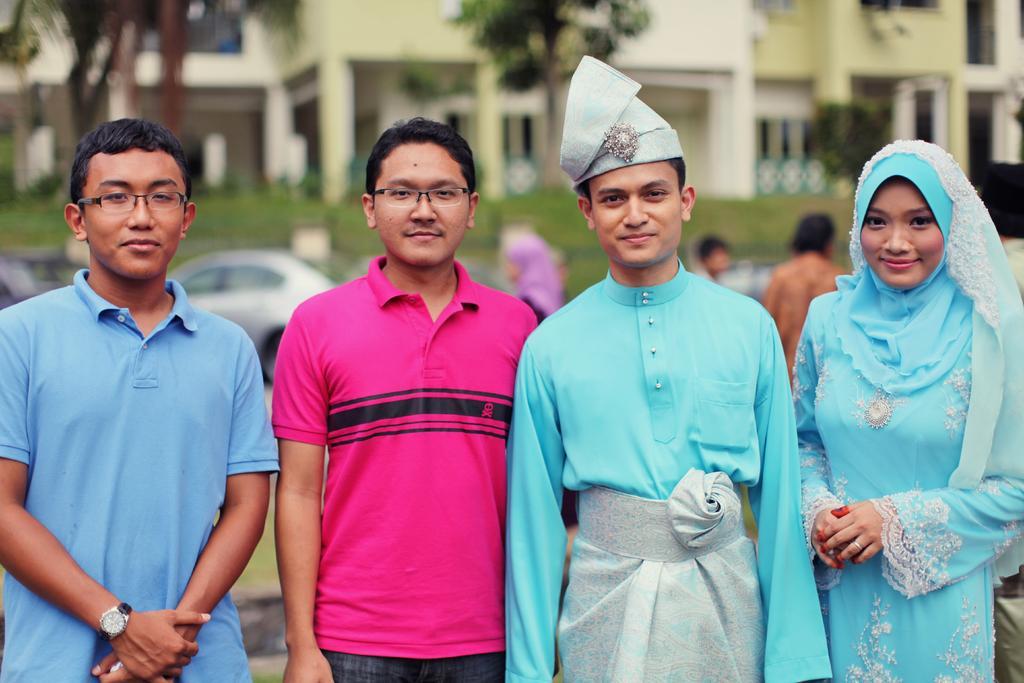In one or two sentences, can you explain what this image depicts? In this image I can see few people are standing. I can see two of them are wearing specs and I can also see smile on few faces. In the background I can see few buildings, trees, few vehicles and I can see this image is little bit blurry from background. 